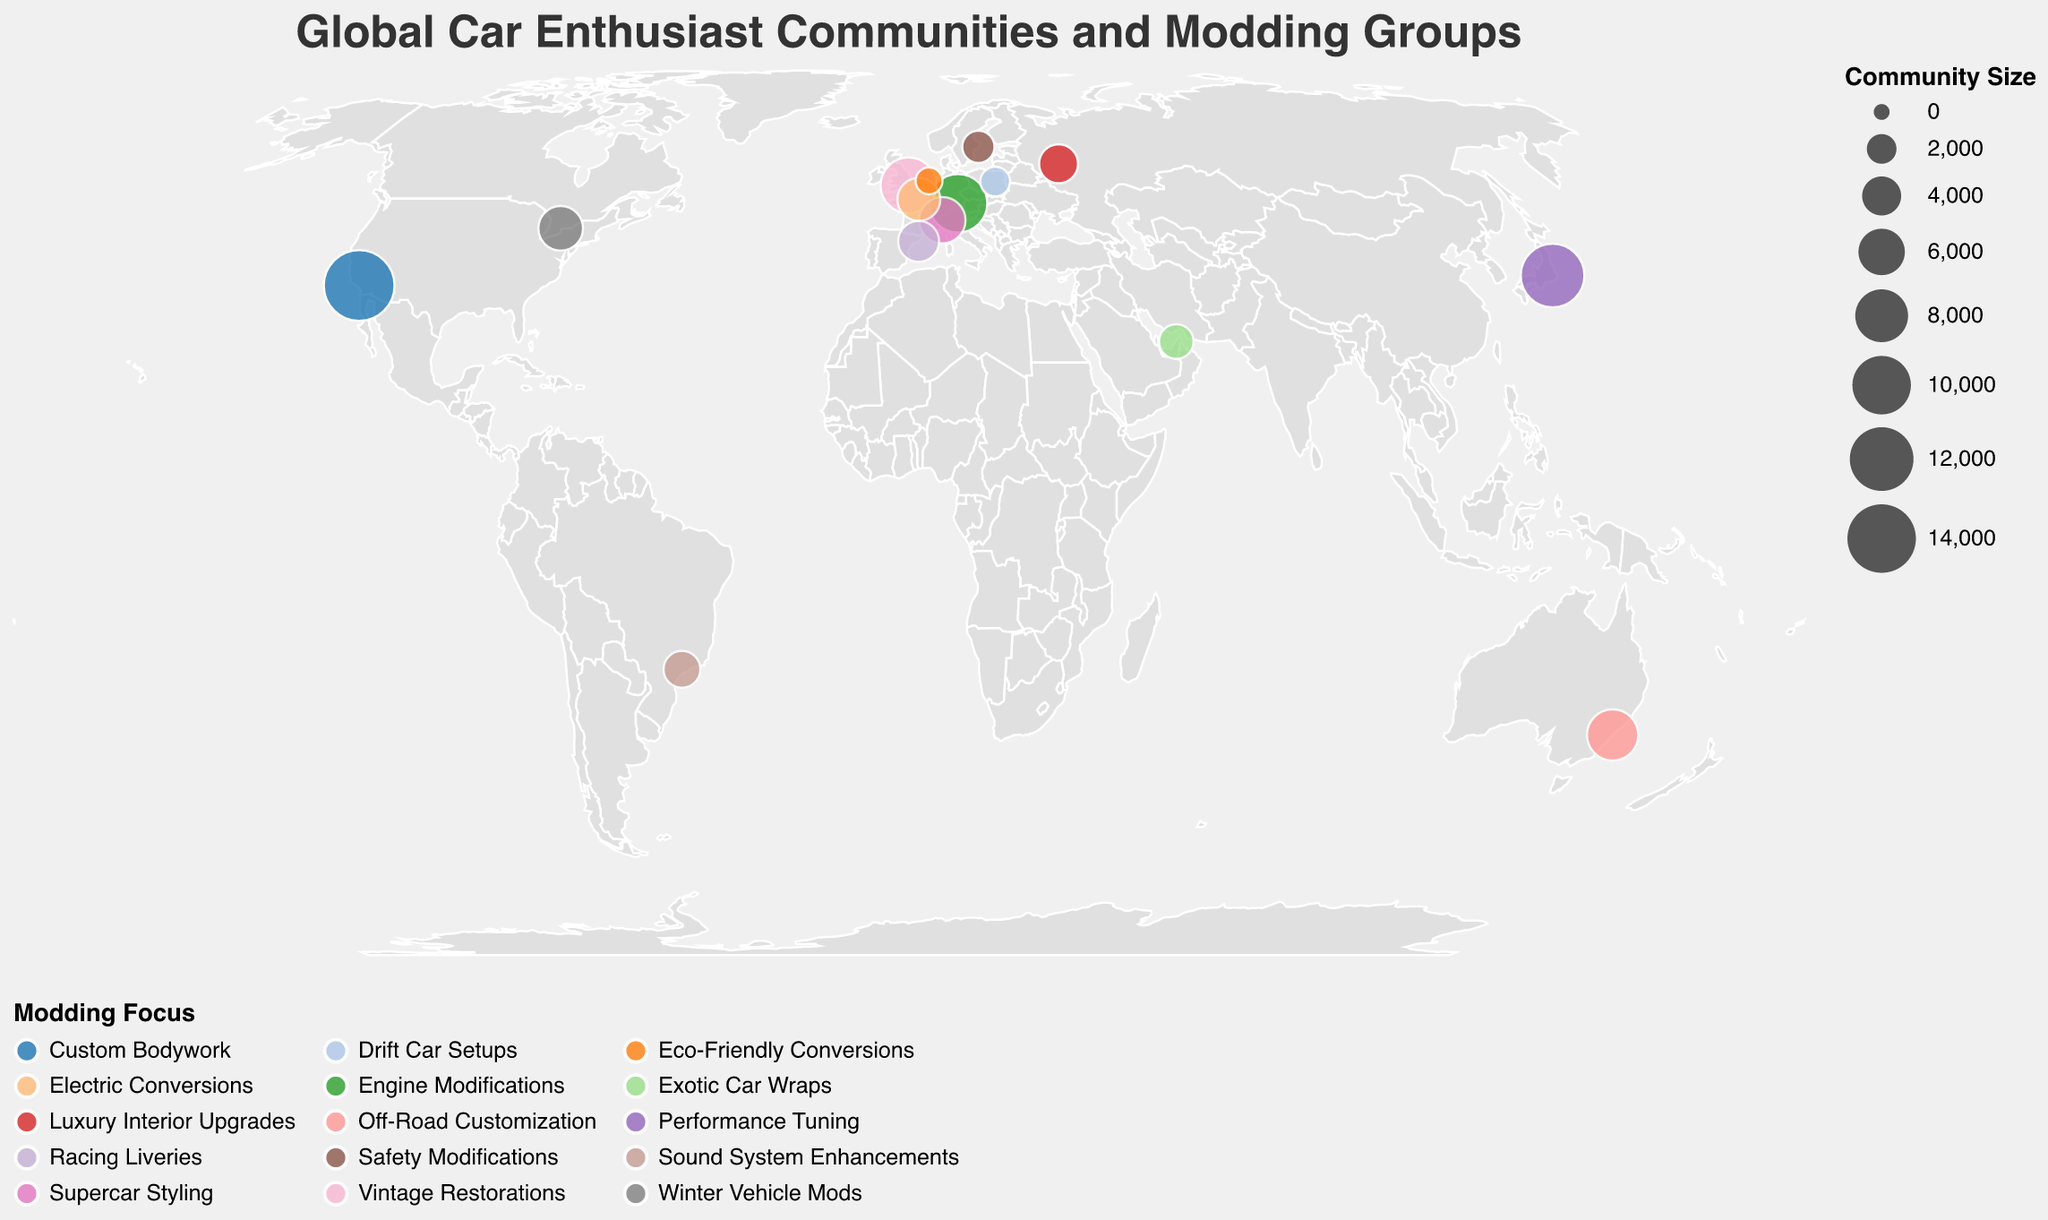What is the community size in Tokyo? Look at the data point for Tokyo in Japan. The community size shown is 12,000.
Answer: 12,000 Which city has the largest community size? Compare the community sizes of all the cities. Los Angeles has the largest community size at 15,000.
Answer: Los Angeles What is the modding focus in Paris? Look at the data point for Paris in France. The modding focus is Electric Conversions.
Answer: Electric Conversions How does the community size of Sao Paulo compare to that of Dubai? The community size in Sao Paulo is 3,500, while in Dubai, it is 3,000. Sao Paulo's community size is larger.
Answer: Sao Paulo's is larger What is the average community size of all cities? Sum all community sizes (15000 + 12000 + 10000 + 9000 + 7500 + 6000 + 5500 + 5000 + 4500 + 4000 + 3500 + 3000 + 2500 + 2000 + 1500 = 91,500) and divide by the number of cities (15). The average is 91,500 / 15 = 6,100.
Answer: 6100 Which city focuses on Supercar Styling? Find the city with the modding focus labeled as Supercar Styling. Turin in Italy has this focus.
Answer: Turin What is the modding focus in Stockholm and how does its community size compare to Amsterdam? Look at the data points for Stockholm and Amsterdam. The modding focus in Stockholm is Safety Modifications. Stockholm has a community size of 2,500, whereas Amsterdam has a community size of 1,500. Therefore, Stockholm’s community size is larger.
Answer: Safety Modifications, Stockholm’s is larger Which city has the smallest community size? Compare the community sizes of all the cities. Amsterdam has the smallest community size at 1,500.
Answer: Amsterdam Which modding focus is associated with the largest community size? Find the modding focus of the city with the largest community size (Los Angeles, 15,000). The modding focus is Custom Bodywork.
Answer: Custom Bodywork What is the sum of community sizes for Tokyo and Munich? Add the community sizes for Tokyo (12,000) and Munich (10,000). The sum is 12,000 + 10,000 = 22,000.
Answer: 22,000 